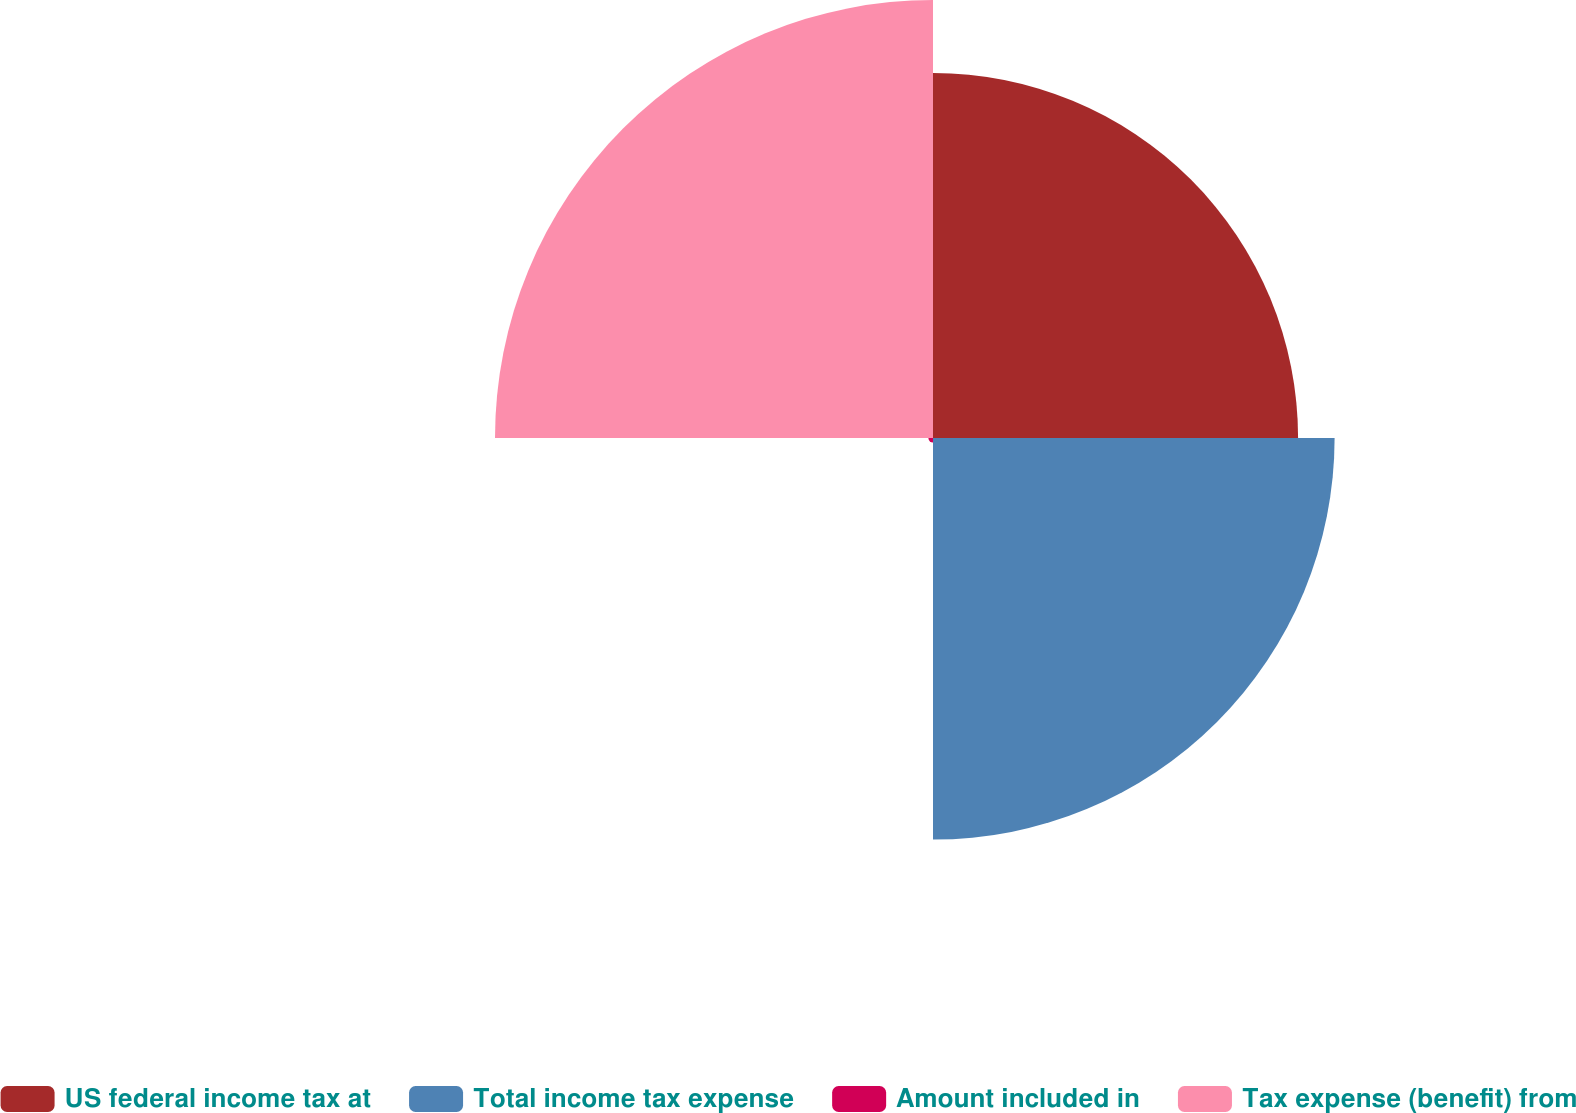<chart> <loc_0><loc_0><loc_500><loc_500><pie_chart><fcel>US federal income tax at<fcel>Total income tax expense<fcel>Amount included in<fcel>Tax expense (benefit) from<nl><fcel>30.19%<fcel>33.21%<fcel>0.38%<fcel>36.22%<nl></chart> 